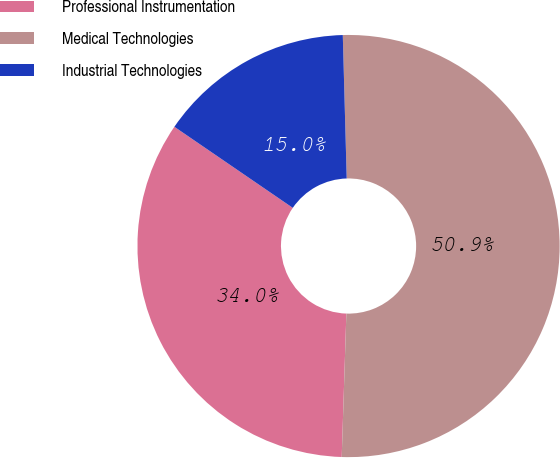<chart> <loc_0><loc_0><loc_500><loc_500><pie_chart><fcel>Professional Instrumentation<fcel>Medical Technologies<fcel>Industrial Technologies<nl><fcel>34.04%<fcel>50.95%<fcel>15.01%<nl></chart> 